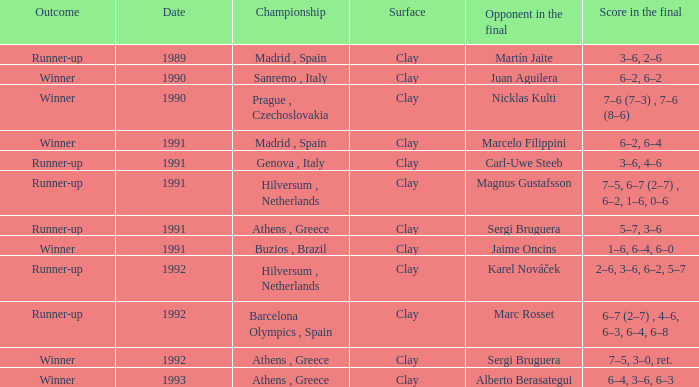If the championship is in athens, greece and the outcome is "winner," what's the final score? 7–5, 3–0, ret., 6–4, 3–6, 6–3. 